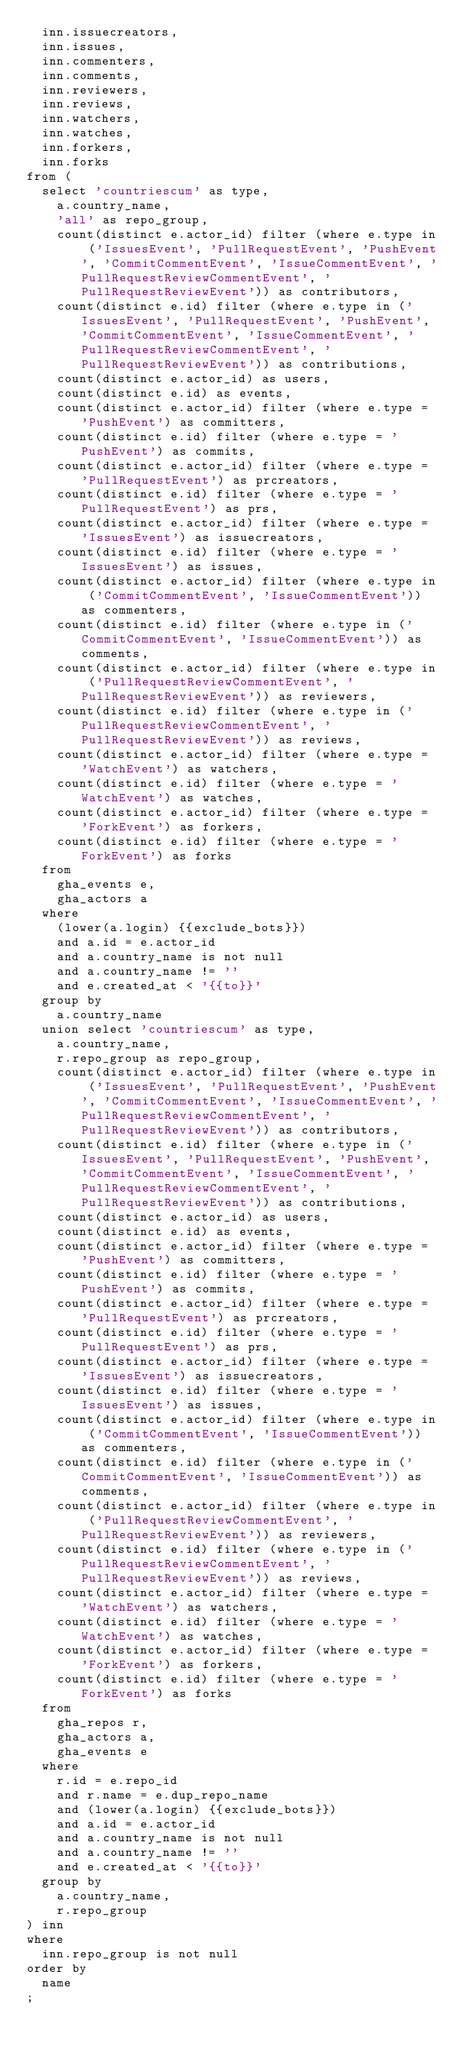<code> <loc_0><loc_0><loc_500><loc_500><_SQL_>  inn.issuecreators,
  inn.issues,
  inn.commenters,
  inn.comments,
  inn.reviewers,
  inn.reviews,
  inn.watchers,
  inn.watches,
  inn.forkers,
  inn.forks
from (
  select 'countriescum' as type,
    a.country_name,
    'all' as repo_group,
    count(distinct e.actor_id) filter (where e.type in ('IssuesEvent', 'PullRequestEvent', 'PushEvent', 'CommitCommentEvent', 'IssueCommentEvent', 'PullRequestReviewCommentEvent', 'PullRequestReviewEvent')) as contributors,
    count(distinct e.id) filter (where e.type in ('IssuesEvent', 'PullRequestEvent', 'PushEvent', 'CommitCommentEvent', 'IssueCommentEvent', 'PullRequestReviewCommentEvent', 'PullRequestReviewEvent')) as contributions,
    count(distinct e.actor_id) as users,
    count(distinct e.id) as events,
    count(distinct e.actor_id) filter (where e.type = 'PushEvent') as committers,
    count(distinct e.id) filter (where e.type = 'PushEvent') as commits,
    count(distinct e.actor_id) filter (where e.type = 'PullRequestEvent') as prcreators,
    count(distinct e.id) filter (where e.type = 'PullRequestEvent') as prs,
    count(distinct e.actor_id) filter (where e.type = 'IssuesEvent') as issuecreators,
    count(distinct e.id) filter (where e.type = 'IssuesEvent') as issues,
    count(distinct e.actor_id) filter (where e.type in ('CommitCommentEvent', 'IssueCommentEvent')) as commenters,
    count(distinct e.id) filter (where e.type in ('CommitCommentEvent', 'IssueCommentEvent')) as comments,
    count(distinct e.actor_id) filter (where e.type in ('PullRequestReviewCommentEvent', 'PullRequestReviewEvent')) as reviewers,
    count(distinct e.id) filter (where e.type in ('PullRequestReviewCommentEvent', 'PullRequestReviewEvent')) as reviews,
    count(distinct e.actor_id) filter (where e.type = 'WatchEvent') as watchers,
    count(distinct e.id) filter (where e.type = 'WatchEvent') as watches,
    count(distinct e.actor_id) filter (where e.type = 'ForkEvent') as forkers,
    count(distinct e.id) filter (where e.type = 'ForkEvent') as forks
  from
    gha_events e,
    gha_actors a
  where
    (lower(a.login) {{exclude_bots}})
    and a.id = e.actor_id
    and a.country_name is not null
    and a.country_name != ''
    and e.created_at < '{{to}}'
  group by
    a.country_name
  union select 'countriescum' as type,
    a.country_name,
    r.repo_group as repo_group,
    count(distinct e.actor_id) filter (where e.type in ('IssuesEvent', 'PullRequestEvent', 'PushEvent', 'CommitCommentEvent', 'IssueCommentEvent', 'PullRequestReviewCommentEvent', 'PullRequestReviewEvent')) as contributors,
    count(distinct e.id) filter (where e.type in ('IssuesEvent', 'PullRequestEvent', 'PushEvent', 'CommitCommentEvent', 'IssueCommentEvent', 'PullRequestReviewCommentEvent', 'PullRequestReviewEvent')) as contributions,
    count(distinct e.actor_id) as users,
    count(distinct e.id) as events,
    count(distinct e.actor_id) filter (where e.type = 'PushEvent') as committers,
    count(distinct e.id) filter (where e.type = 'PushEvent') as commits,
    count(distinct e.actor_id) filter (where e.type = 'PullRequestEvent') as prcreators,
    count(distinct e.id) filter (where e.type = 'PullRequestEvent') as prs,
    count(distinct e.actor_id) filter (where e.type = 'IssuesEvent') as issuecreators,
    count(distinct e.id) filter (where e.type = 'IssuesEvent') as issues,
    count(distinct e.actor_id) filter (where e.type in ('CommitCommentEvent', 'IssueCommentEvent')) as commenters,
    count(distinct e.id) filter (where e.type in ('CommitCommentEvent', 'IssueCommentEvent')) as comments,
    count(distinct e.actor_id) filter (where e.type in ('PullRequestReviewCommentEvent', 'PullRequestReviewEvent')) as reviewers,
    count(distinct e.id) filter (where e.type in ('PullRequestReviewCommentEvent', 'PullRequestReviewEvent')) as reviews,
    count(distinct e.actor_id) filter (where e.type = 'WatchEvent') as watchers,
    count(distinct e.id) filter (where e.type = 'WatchEvent') as watches,
    count(distinct e.actor_id) filter (where e.type = 'ForkEvent') as forkers,
    count(distinct e.id) filter (where e.type = 'ForkEvent') as forks
  from
    gha_repos r,
    gha_actors a,
    gha_events e
  where
    r.id = e.repo_id
    and r.name = e.dup_repo_name
    and (lower(a.login) {{exclude_bots}})
    and a.id = e.actor_id
    and a.country_name is not null
    and a.country_name != ''
    and e.created_at < '{{to}}'
  group by
    a.country_name,
    r.repo_group
) inn
where
  inn.repo_group is not null 
order by
  name
;
</code> 